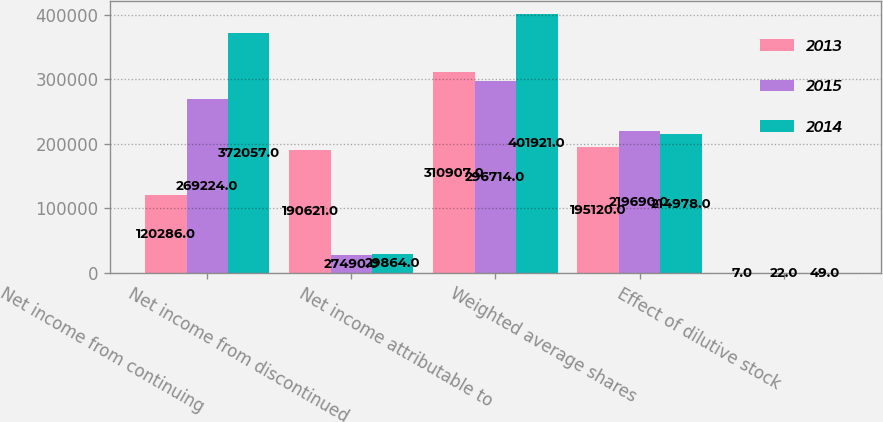<chart> <loc_0><loc_0><loc_500><loc_500><stacked_bar_chart><ecel><fcel>Net income from continuing<fcel>Net income from discontinued<fcel>Net income attributable to<fcel>Weighted average shares<fcel>Effect of dilutive stock<nl><fcel>2013<fcel>120286<fcel>190621<fcel>310907<fcel>195120<fcel>7<nl><fcel>2015<fcel>269224<fcel>27490<fcel>296714<fcel>219690<fcel>22<nl><fcel>2014<fcel>372057<fcel>29864<fcel>401921<fcel>214978<fcel>49<nl></chart> 